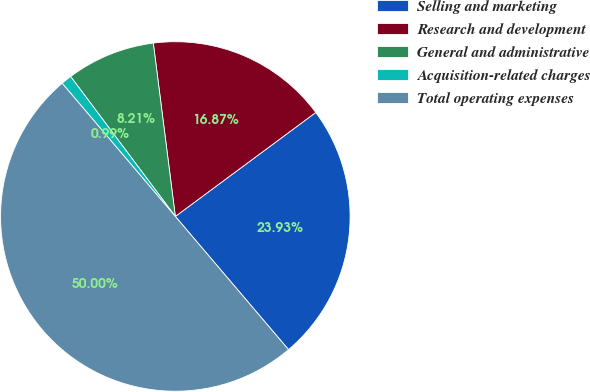<chart> <loc_0><loc_0><loc_500><loc_500><pie_chart><fcel>Selling and marketing<fcel>Research and development<fcel>General and administrative<fcel>Acquisition-related charges<fcel>Total operating expenses<nl><fcel>23.93%<fcel>16.87%<fcel>8.21%<fcel>0.99%<fcel>50.0%<nl></chart> 